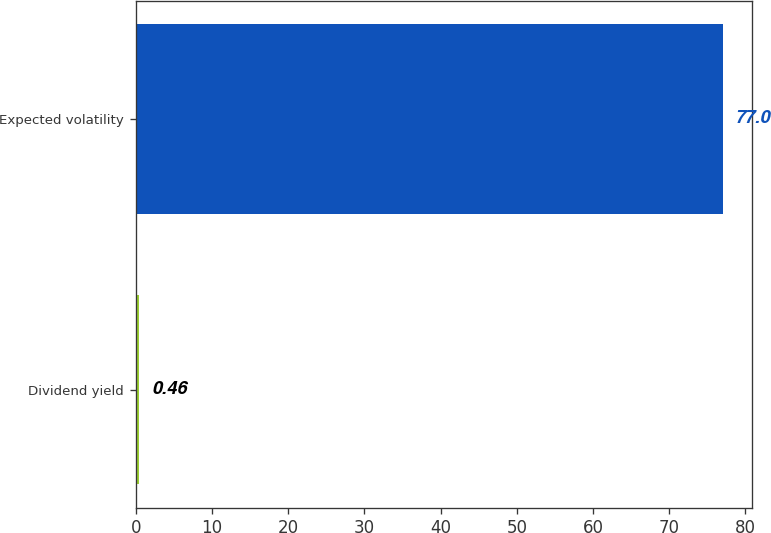<chart> <loc_0><loc_0><loc_500><loc_500><bar_chart><fcel>Dividend yield<fcel>Expected volatility<nl><fcel>0.46<fcel>77<nl></chart> 